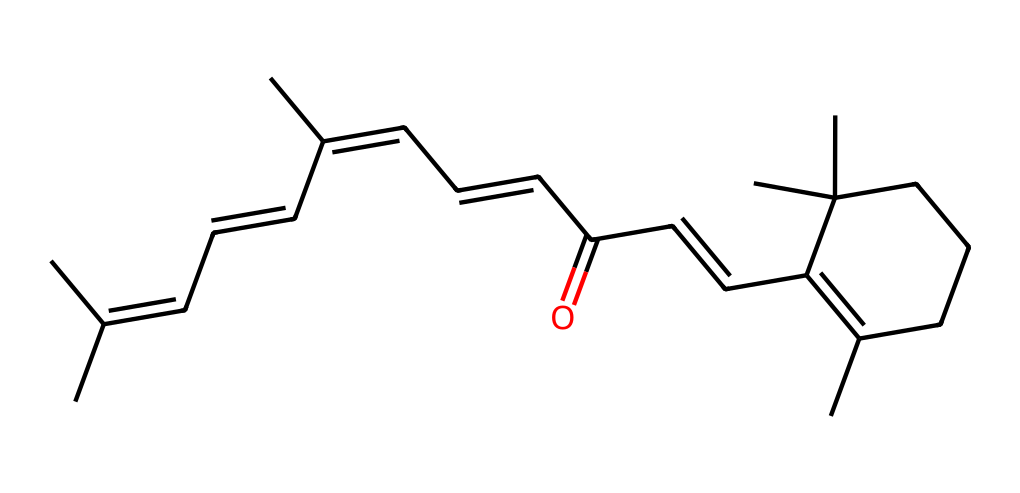What is the functional group present in this chemical? The structure contains a carbonyl group (C=O) at the end of the carbon chain, which indicates that it is an aldehyde.
Answer: aldehyde How many carbon atoms are there in retinal? By counting the carbon atoms in the SMILES representation, there are 20 carbon atoms present in retinal.
Answer: 20 What type of bond is primarily found in the aldehyde functional group? The aldehyde functional group is characterized by a double bond between carbon and oxygen (C=O), which is specific to its structure.
Answer: double bond What is the number of double bonds in the structure of retinal? Analyzing the SMILES representation shows a total of 5 double bonds in retinal, including the one in the carbonyl group.
Answer: 5 How does the presence of the aldehyde functional group affect the reactivity of retinal? The aldehyde group is highly reactive due to the electrophilic nature of the carbonyl carbon, leading to reactions such as oxidation or addition with nucleophiles.
Answer: increases reactivity Is retinal saturated or unsaturated? The presence of double bonds in the structure indicates that it is unsaturated, meaning it does not contain the maximum number of hydrogen atoms.
Answer: unsaturated 